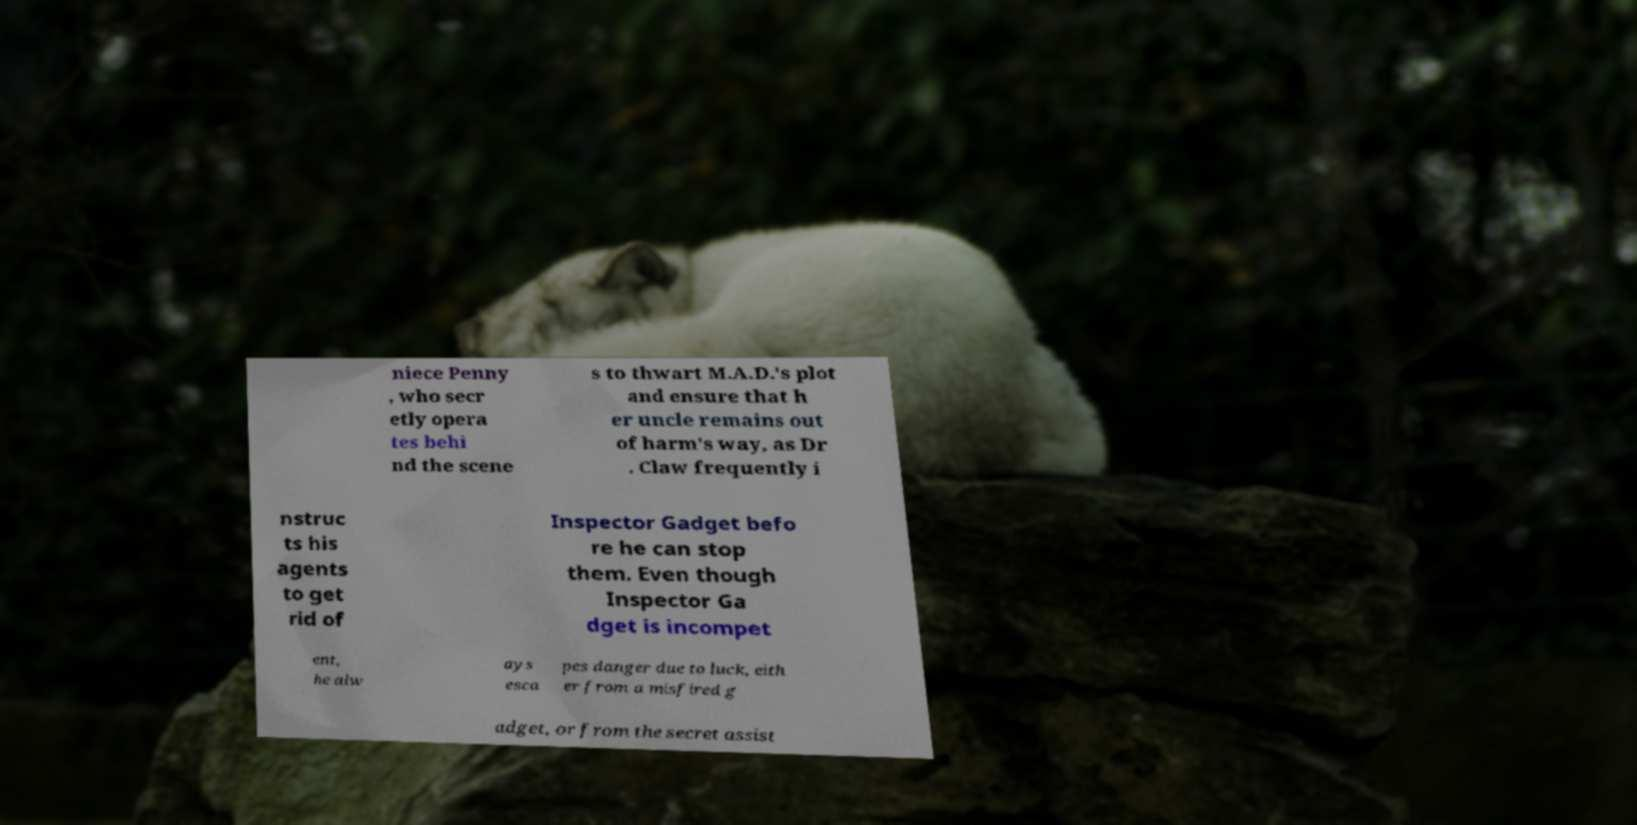Could you extract and type out the text from this image? niece Penny , who secr etly opera tes behi nd the scene s to thwart M.A.D.'s plot and ensure that h er uncle remains out of harm's way, as Dr . Claw frequently i nstruc ts his agents to get rid of Inspector Gadget befo re he can stop them. Even though Inspector Ga dget is incompet ent, he alw ays esca pes danger due to luck, eith er from a misfired g adget, or from the secret assist 